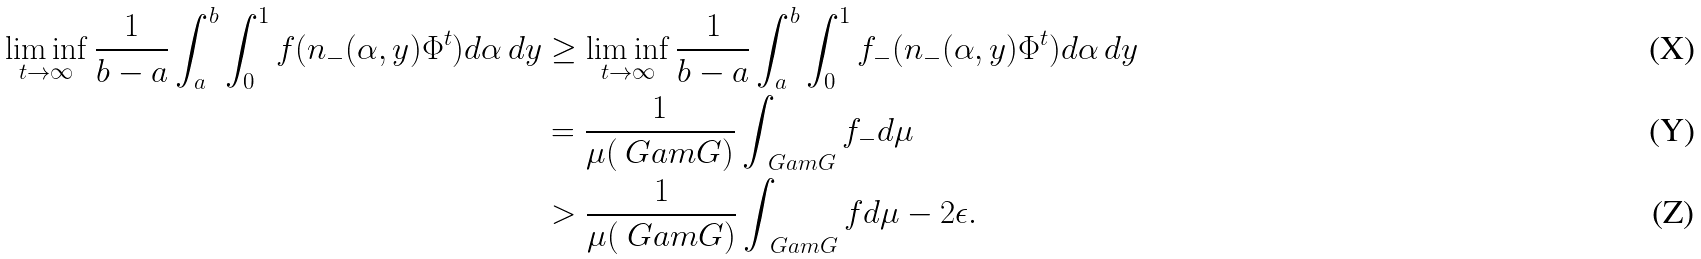<formula> <loc_0><loc_0><loc_500><loc_500>\liminf _ { t \to \infty } \frac { 1 } { b - a } \int _ { a } ^ { b } \int _ { 0 } ^ { 1 } f ( n _ { - } ( \alpha , y ) \Phi ^ { t } ) d \alpha \, d y & \geq \liminf _ { t \to \infty } \frac { 1 } { b - a } \int _ { a } ^ { b } \int _ { 0 } ^ { 1 } f _ { - } ( n _ { - } ( \alpha , y ) \Phi ^ { t } ) d \alpha \, d y \\ & = \frac { 1 } { \mu ( \ G a m G ) } \int _ { \ G a m G } f _ { - } d \mu \\ & > \frac { 1 } { \mu ( \ G a m G ) } \int _ { \ G a m G } f d \mu - 2 \epsilon .</formula> 